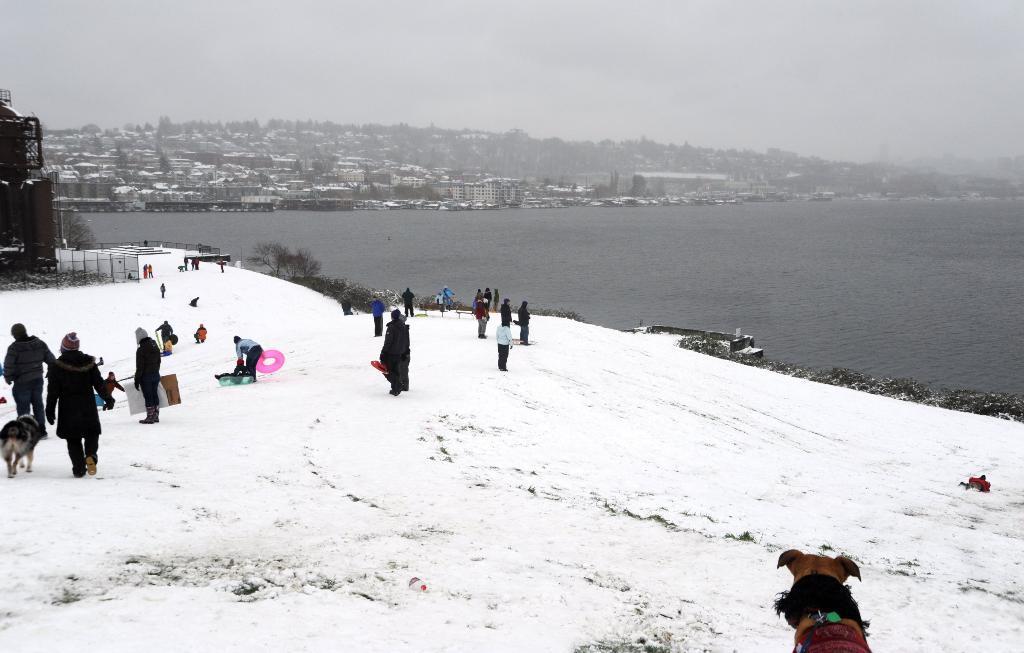Describe this image in one or two sentences. There is snow on the ground. On that there are many people, dogs. Also there is a building on the left side. In the background there is water, buildings and sky. Also there are trees. And some people are holding something. 